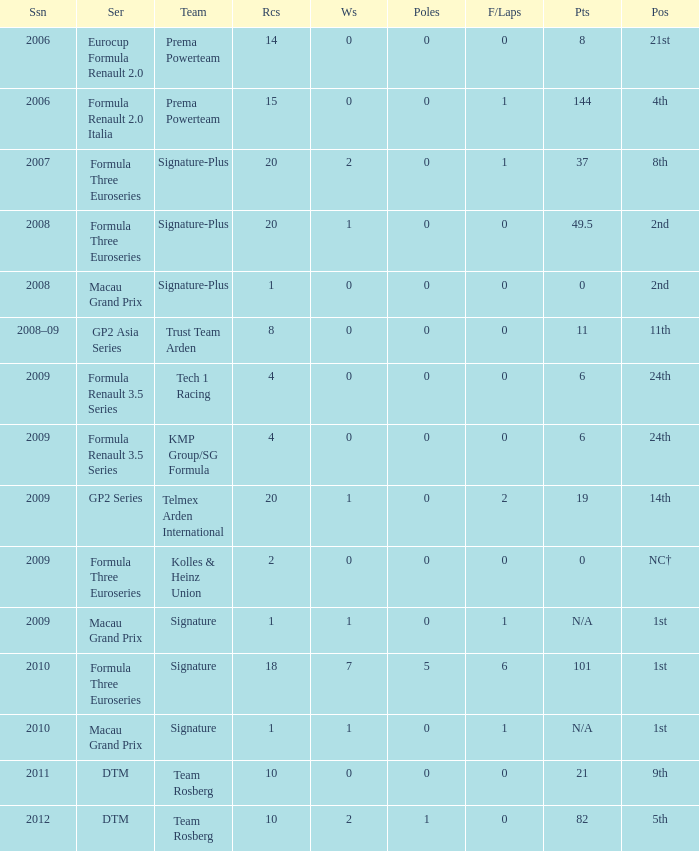Could you parse the entire table as a dict? {'header': ['Ssn', 'Ser', 'Team', 'Rcs', 'Ws', 'Poles', 'F/Laps', 'Pts', 'Pos'], 'rows': [['2006', 'Eurocup Formula Renault 2.0', 'Prema Powerteam', '14', '0', '0', '0', '8', '21st'], ['2006', 'Formula Renault 2.0 Italia', 'Prema Powerteam', '15', '0', '0', '1', '144', '4th'], ['2007', 'Formula Three Euroseries', 'Signature-Plus', '20', '2', '0', '1', '37', '8th'], ['2008', 'Formula Three Euroseries', 'Signature-Plus', '20', '1', '0', '0', '49.5', '2nd'], ['2008', 'Macau Grand Prix', 'Signature-Plus', '1', '0', '0', '0', '0', '2nd'], ['2008–09', 'GP2 Asia Series', 'Trust Team Arden', '8', '0', '0', '0', '11', '11th'], ['2009', 'Formula Renault 3.5 Series', 'Tech 1 Racing', '4', '0', '0', '0', '6', '24th'], ['2009', 'Formula Renault 3.5 Series', 'KMP Group/SG Formula', '4', '0', '0', '0', '6', '24th'], ['2009', 'GP2 Series', 'Telmex Arden International', '20', '1', '0', '2', '19', '14th'], ['2009', 'Formula Three Euroseries', 'Kolles & Heinz Union', '2', '0', '0', '0', '0', 'NC†'], ['2009', 'Macau Grand Prix', 'Signature', '1', '1', '0', '1', 'N/A', '1st'], ['2010', 'Formula Three Euroseries', 'Signature', '18', '7', '5', '6', '101', '1st'], ['2010', 'Macau Grand Prix', 'Signature', '1', '1', '0', '1', 'N/A', '1st'], ['2011', 'DTM', 'Team Rosberg', '10', '0', '0', '0', '21', '9th'], ['2012', 'DTM', 'Team Rosberg', '10', '2', '1', '0', '82', '5th']]} How many poles are there in the Formula Three Euroseries in the 2008 season with more than 0 F/Laps? None. 